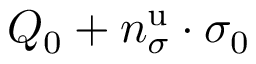<formula> <loc_0><loc_0><loc_500><loc_500>Q _ { 0 } + n _ { \sigma } ^ { u } \cdot \sigma _ { 0 }</formula> 